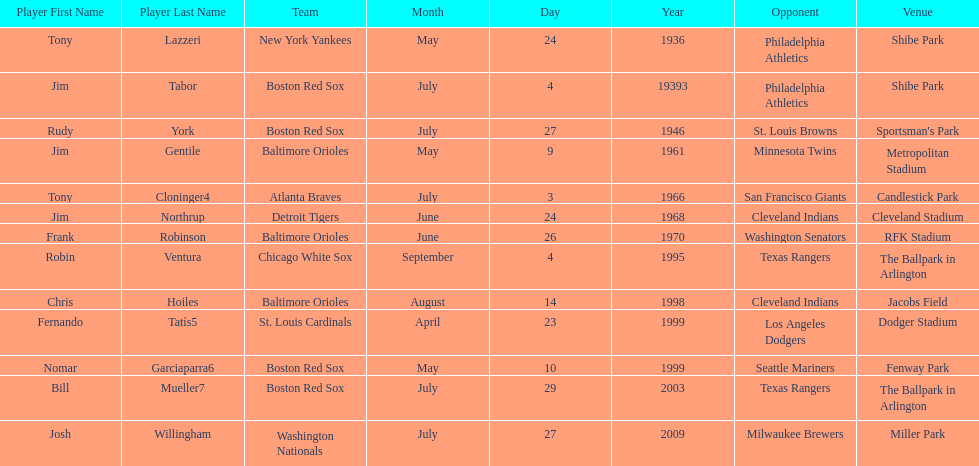What were the dates of each game? May 24, 1936, July 4, 19393, July 27, 1946, May 9, 1961, July 3, 1966, June 24, 1968, June 26, 1970, September 4, 1995, August 14, 1998, April 23, 1999, May 10, 1999, July 29, 2003, July 27, 2009. Who were all of the teams? New York Yankees, Boston Red Sox, Boston Red Sox, Baltimore Orioles, Atlanta Braves, Detroit Tigers, Baltimore Orioles, Chicago White Sox, Baltimore Orioles, St. Louis Cardinals, Boston Red Sox, Boston Red Sox, Washington Nationals. What about their opponents? Philadelphia Athletics, Philadelphia Athletics, St. Louis Browns, Minnesota Twins, San Francisco Giants, Cleveland Indians, Washington Senators, Texas Rangers, Cleveland Indians, Los Angeles Dodgers, Seattle Mariners, Texas Rangers, Milwaukee Brewers. And on which date did the detroit tigers play against the cleveland indians? June 24, 1968. 